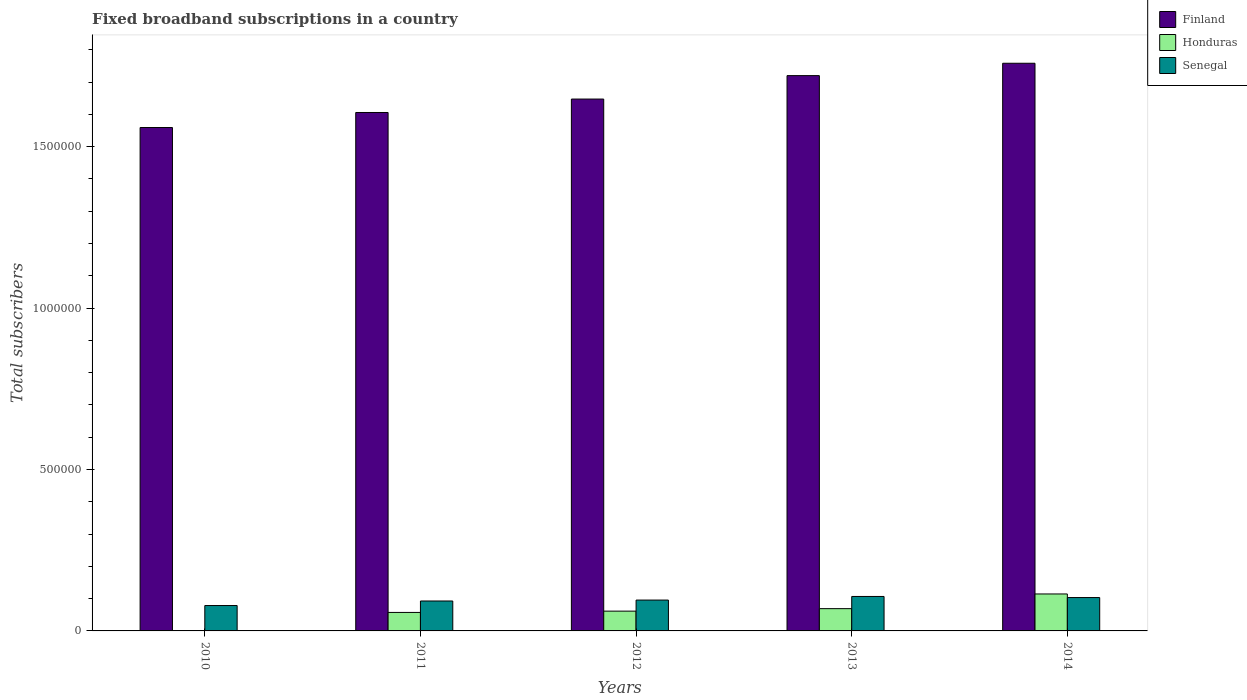How many different coloured bars are there?
Your answer should be compact. 3. Are the number of bars per tick equal to the number of legend labels?
Give a very brief answer. Yes. Are the number of bars on each tick of the X-axis equal?
Your response must be concise. Yes. How many bars are there on the 2nd tick from the left?
Ensure brevity in your answer.  3. What is the number of broadband subscriptions in Finland in 2011?
Your answer should be compact. 1.61e+06. Across all years, what is the maximum number of broadband subscriptions in Finland?
Ensure brevity in your answer.  1.76e+06. Across all years, what is the minimum number of broadband subscriptions in Senegal?
Provide a succinct answer. 7.86e+04. What is the total number of broadband subscriptions in Senegal in the graph?
Keep it short and to the point. 4.77e+05. What is the difference between the number of broadband subscriptions in Honduras in 2012 and that in 2013?
Provide a short and direct response. -7714. What is the difference between the number of broadband subscriptions in Finland in 2010 and the number of broadband subscriptions in Honduras in 2013?
Offer a very short reply. 1.49e+06. What is the average number of broadband subscriptions in Senegal per year?
Your answer should be very brief. 9.54e+04. In the year 2010, what is the difference between the number of broadband subscriptions in Finland and number of broadband subscriptions in Senegal?
Offer a terse response. 1.48e+06. What is the ratio of the number of broadband subscriptions in Senegal in 2012 to that in 2014?
Ensure brevity in your answer.  0.92. Is the difference between the number of broadband subscriptions in Finland in 2013 and 2014 greater than the difference between the number of broadband subscriptions in Senegal in 2013 and 2014?
Ensure brevity in your answer.  No. What is the difference between the highest and the second highest number of broadband subscriptions in Senegal?
Offer a very short reply. 3371. What is the difference between the highest and the lowest number of broadband subscriptions in Senegal?
Provide a succinct answer. 2.81e+04. In how many years, is the number of broadband subscriptions in Honduras greater than the average number of broadband subscriptions in Honduras taken over all years?
Make the answer very short. 3. What does the 2nd bar from the left in 2014 represents?
Offer a terse response. Honduras. What does the 1st bar from the right in 2010 represents?
Offer a very short reply. Senegal. How many bars are there?
Offer a very short reply. 15. Are all the bars in the graph horizontal?
Your answer should be very brief. No. Are the values on the major ticks of Y-axis written in scientific E-notation?
Your answer should be compact. No. Does the graph contain any zero values?
Your response must be concise. No. How many legend labels are there?
Ensure brevity in your answer.  3. What is the title of the graph?
Your response must be concise. Fixed broadband subscriptions in a country. What is the label or title of the Y-axis?
Your response must be concise. Total subscribers. What is the Total subscribers in Finland in 2010?
Offer a very short reply. 1.56e+06. What is the Total subscribers in Honduras in 2010?
Offer a terse response. 1000. What is the Total subscribers of Senegal in 2010?
Your answer should be very brief. 7.86e+04. What is the Total subscribers of Finland in 2011?
Provide a succinct answer. 1.61e+06. What is the Total subscribers of Honduras in 2011?
Ensure brevity in your answer.  5.73e+04. What is the Total subscribers in Senegal in 2011?
Give a very brief answer. 9.27e+04. What is the Total subscribers in Finland in 2012?
Offer a terse response. 1.65e+06. What is the Total subscribers of Honduras in 2012?
Provide a short and direct response. 6.13e+04. What is the Total subscribers in Senegal in 2012?
Offer a very short reply. 9.56e+04. What is the Total subscribers of Finland in 2013?
Your answer should be very brief. 1.72e+06. What is the Total subscribers of Honduras in 2013?
Make the answer very short. 6.90e+04. What is the Total subscribers of Senegal in 2013?
Give a very brief answer. 1.07e+05. What is the Total subscribers of Finland in 2014?
Keep it short and to the point. 1.76e+06. What is the Total subscribers of Honduras in 2014?
Your answer should be compact. 1.14e+05. What is the Total subscribers of Senegal in 2014?
Your response must be concise. 1.03e+05. Across all years, what is the maximum Total subscribers of Finland?
Your answer should be very brief. 1.76e+06. Across all years, what is the maximum Total subscribers of Honduras?
Provide a succinct answer. 1.14e+05. Across all years, what is the maximum Total subscribers in Senegal?
Make the answer very short. 1.07e+05. Across all years, what is the minimum Total subscribers in Finland?
Offer a very short reply. 1.56e+06. Across all years, what is the minimum Total subscribers in Honduras?
Offer a terse response. 1000. Across all years, what is the minimum Total subscribers of Senegal?
Provide a short and direct response. 7.86e+04. What is the total Total subscribers in Finland in the graph?
Your answer should be compact. 8.29e+06. What is the total Total subscribers in Honduras in the graph?
Your response must be concise. 3.03e+05. What is the total Total subscribers in Senegal in the graph?
Offer a terse response. 4.77e+05. What is the difference between the Total subscribers of Finland in 2010 and that in 2011?
Offer a very short reply. -4.66e+04. What is the difference between the Total subscribers of Honduras in 2010 and that in 2011?
Give a very brief answer. -5.63e+04. What is the difference between the Total subscribers in Senegal in 2010 and that in 2011?
Your answer should be very brief. -1.41e+04. What is the difference between the Total subscribers in Finland in 2010 and that in 2012?
Your answer should be compact. -8.82e+04. What is the difference between the Total subscribers of Honduras in 2010 and that in 2012?
Provide a succinct answer. -6.03e+04. What is the difference between the Total subscribers of Senegal in 2010 and that in 2012?
Your answer should be very brief. -1.69e+04. What is the difference between the Total subscribers in Finland in 2010 and that in 2013?
Your answer should be compact. -1.61e+05. What is the difference between the Total subscribers of Honduras in 2010 and that in 2013?
Keep it short and to the point. -6.80e+04. What is the difference between the Total subscribers of Senegal in 2010 and that in 2013?
Your answer should be very brief. -2.81e+04. What is the difference between the Total subscribers of Finland in 2010 and that in 2014?
Keep it short and to the point. -1.99e+05. What is the difference between the Total subscribers in Honduras in 2010 and that in 2014?
Make the answer very short. -1.13e+05. What is the difference between the Total subscribers in Senegal in 2010 and that in 2014?
Provide a short and direct response. -2.47e+04. What is the difference between the Total subscribers of Finland in 2011 and that in 2012?
Your answer should be compact. -4.16e+04. What is the difference between the Total subscribers of Honduras in 2011 and that in 2012?
Make the answer very short. -3987. What is the difference between the Total subscribers of Senegal in 2011 and that in 2012?
Ensure brevity in your answer.  -2848. What is the difference between the Total subscribers of Finland in 2011 and that in 2013?
Give a very brief answer. -1.14e+05. What is the difference between the Total subscribers in Honduras in 2011 and that in 2013?
Offer a terse response. -1.17e+04. What is the difference between the Total subscribers of Senegal in 2011 and that in 2013?
Your answer should be compact. -1.40e+04. What is the difference between the Total subscribers of Finland in 2011 and that in 2014?
Keep it short and to the point. -1.52e+05. What is the difference between the Total subscribers of Honduras in 2011 and that in 2014?
Offer a very short reply. -5.72e+04. What is the difference between the Total subscribers in Senegal in 2011 and that in 2014?
Provide a succinct answer. -1.06e+04. What is the difference between the Total subscribers in Finland in 2012 and that in 2013?
Offer a terse response. -7.26e+04. What is the difference between the Total subscribers in Honduras in 2012 and that in 2013?
Offer a very short reply. -7714. What is the difference between the Total subscribers of Senegal in 2012 and that in 2013?
Offer a terse response. -1.12e+04. What is the difference between the Total subscribers of Finland in 2012 and that in 2014?
Give a very brief answer. -1.11e+05. What is the difference between the Total subscribers of Honduras in 2012 and that in 2014?
Offer a very short reply. -5.32e+04. What is the difference between the Total subscribers in Senegal in 2012 and that in 2014?
Provide a succinct answer. -7801. What is the difference between the Total subscribers in Finland in 2013 and that in 2014?
Provide a short and direct response. -3.83e+04. What is the difference between the Total subscribers in Honduras in 2013 and that in 2014?
Offer a very short reply. -4.55e+04. What is the difference between the Total subscribers in Senegal in 2013 and that in 2014?
Your answer should be very brief. 3371. What is the difference between the Total subscribers in Finland in 2010 and the Total subscribers in Honduras in 2011?
Ensure brevity in your answer.  1.50e+06. What is the difference between the Total subscribers of Finland in 2010 and the Total subscribers of Senegal in 2011?
Give a very brief answer. 1.47e+06. What is the difference between the Total subscribers in Honduras in 2010 and the Total subscribers in Senegal in 2011?
Ensure brevity in your answer.  -9.17e+04. What is the difference between the Total subscribers of Finland in 2010 and the Total subscribers of Honduras in 2012?
Your answer should be very brief. 1.50e+06. What is the difference between the Total subscribers of Finland in 2010 and the Total subscribers of Senegal in 2012?
Offer a very short reply. 1.46e+06. What is the difference between the Total subscribers in Honduras in 2010 and the Total subscribers in Senegal in 2012?
Keep it short and to the point. -9.46e+04. What is the difference between the Total subscribers of Finland in 2010 and the Total subscribers of Honduras in 2013?
Keep it short and to the point. 1.49e+06. What is the difference between the Total subscribers in Finland in 2010 and the Total subscribers in Senegal in 2013?
Ensure brevity in your answer.  1.45e+06. What is the difference between the Total subscribers in Honduras in 2010 and the Total subscribers in Senegal in 2013?
Your response must be concise. -1.06e+05. What is the difference between the Total subscribers in Finland in 2010 and the Total subscribers in Honduras in 2014?
Offer a very short reply. 1.44e+06. What is the difference between the Total subscribers in Finland in 2010 and the Total subscribers in Senegal in 2014?
Ensure brevity in your answer.  1.46e+06. What is the difference between the Total subscribers in Honduras in 2010 and the Total subscribers in Senegal in 2014?
Offer a very short reply. -1.02e+05. What is the difference between the Total subscribers of Finland in 2011 and the Total subscribers of Honduras in 2012?
Your answer should be very brief. 1.54e+06. What is the difference between the Total subscribers in Finland in 2011 and the Total subscribers in Senegal in 2012?
Your answer should be very brief. 1.51e+06. What is the difference between the Total subscribers of Honduras in 2011 and the Total subscribers of Senegal in 2012?
Give a very brief answer. -3.83e+04. What is the difference between the Total subscribers in Finland in 2011 and the Total subscribers in Honduras in 2013?
Make the answer very short. 1.54e+06. What is the difference between the Total subscribers in Finland in 2011 and the Total subscribers in Senegal in 2013?
Offer a very short reply. 1.50e+06. What is the difference between the Total subscribers in Honduras in 2011 and the Total subscribers in Senegal in 2013?
Offer a terse response. -4.94e+04. What is the difference between the Total subscribers in Finland in 2011 and the Total subscribers in Honduras in 2014?
Ensure brevity in your answer.  1.49e+06. What is the difference between the Total subscribers of Finland in 2011 and the Total subscribers of Senegal in 2014?
Your answer should be compact. 1.50e+06. What is the difference between the Total subscribers of Honduras in 2011 and the Total subscribers of Senegal in 2014?
Make the answer very short. -4.61e+04. What is the difference between the Total subscribers in Finland in 2012 and the Total subscribers in Honduras in 2013?
Give a very brief answer. 1.58e+06. What is the difference between the Total subscribers in Finland in 2012 and the Total subscribers in Senegal in 2013?
Offer a terse response. 1.54e+06. What is the difference between the Total subscribers in Honduras in 2012 and the Total subscribers in Senegal in 2013?
Give a very brief answer. -4.55e+04. What is the difference between the Total subscribers of Finland in 2012 and the Total subscribers of Honduras in 2014?
Provide a succinct answer. 1.53e+06. What is the difference between the Total subscribers in Finland in 2012 and the Total subscribers in Senegal in 2014?
Provide a short and direct response. 1.54e+06. What is the difference between the Total subscribers in Honduras in 2012 and the Total subscribers in Senegal in 2014?
Provide a short and direct response. -4.21e+04. What is the difference between the Total subscribers in Finland in 2013 and the Total subscribers in Honduras in 2014?
Your answer should be very brief. 1.61e+06. What is the difference between the Total subscribers of Finland in 2013 and the Total subscribers of Senegal in 2014?
Keep it short and to the point. 1.62e+06. What is the difference between the Total subscribers of Honduras in 2013 and the Total subscribers of Senegal in 2014?
Your answer should be very brief. -3.44e+04. What is the average Total subscribers in Finland per year?
Your answer should be very brief. 1.66e+06. What is the average Total subscribers in Honduras per year?
Your response must be concise. 6.06e+04. What is the average Total subscribers in Senegal per year?
Provide a short and direct response. 9.54e+04. In the year 2010, what is the difference between the Total subscribers of Finland and Total subscribers of Honduras?
Provide a short and direct response. 1.56e+06. In the year 2010, what is the difference between the Total subscribers of Finland and Total subscribers of Senegal?
Give a very brief answer. 1.48e+06. In the year 2010, what is the difference between the Total subscribers of Honduras and Total subscribers of Senegal?
Your answer should be very brief. -7.76e+04. In the year 2011, what is the difference between the Total subscribers in Finland and Total subscribers in Honduras?
Give a very brief answer. 1.55e+06. In the year 2011, what is the difference between the Total subscribers of Finland and Total subscribers of Senegal?
Provide a short and direct response. 1.51e+06. In the year 2011, what is the difference between the Total subscribers of Honduras and Total subscribers of Senegal?
Your response must be concise. -3.54e+04. In the year 2012, what is the difference between the Total subscribers in Finland and Total subscribers in Honduras?
Offer a terse response. 1.59e+06. In the year 2012, what is the difference between the Total subscribers of Finland and Total subscribers of Senegal?
Offer a terse response. 1.55e+06. In the year 2012, what is the difference between the Total subscribers in Honduras and Total subscribers in Senegal?
Provide a succinct answer. -3.43e+04. In the year 2013, what is the difference between the Total subscribers in Finland and Total subscribers in Honduras?
Make the answer very short. 1.65e+06. In the year 2013, what is the difference between the Total subscribers of Finland and Total subscribers of Senegal?
Offer a very short reply. 1.61e+06. In the year 2013, what is the difference between the Total subscribers in Honduras and Total subscribers in Senegal?
Provide a short and direct response. -3.77e+04. In the year 2014, what is the difference between the Total subscribers in Finland and Total subscribers in Honduras?
Your answer should be very brief. 1.64e+06. In the year 2014, what is the difference between the Total subscribers in Finland and Total subscribers in Senegal?
Provide a short and direct response. 1.66e+06. In the year 2014, what is the difference between the Total subscribers in Honduras and Total subscribers in Senegal?
Give a very brief answer. 1.11e+04. What is the ratio of the Total subscribers of Finland in 2010 to that in 2011?
Your response must be concise. 0.97. What is the ratio of the Total subscribers of Honduras in 2010 to that in 2011?
Provide a short and direct response. 0.02. What is the ratio of the Total subscribers of Senegal in 2010 to that in 2011?
Your answer should be compact. 0.85. What is the ratio of the Total subscribers of Finland in 2010 to that in 2012?
Ensure brevity in your answer.  0.95. What is the ratio of the Total subscribers in Honduras in 2010 to that in 2012?
Give a very brief answer. 0.02. What is the ratio of the Total subscribers of Senegal in 2010 to that in 2012?
Provide a short and direct response. 0.82. What is the ratio of the Total subscribers of Finland in 2010 to that in 2013?
Offer a very short reply. 0.91. What is the ratio of the Total subscribers of Honduras in 2010 to that in 2013?
Offer a very short reply. 0.01. What is the ratio of the Total subscribers of Senegal in 2010 to that in 2013?
Make the answer very short. 0.74. What is the ratio of the Total subscribers in Finland in 2010 to that in 2014?
Your answer should be compact. 0.89. What is the ratio of the Total subscribers of Honduras in 2010 to that in 2014?
Give a very brief answer. 0.01. What is the ratio of the Total subscribers of Senegal in 2010 to that in 2014?
Your answer should be very brief. 0.76. What is the ratio of the Total subscribers in Finland in 2011 to that in 2012?
Ensure brevity in your answer.  0.97. What is the ratio of the Total subscribers of Honduras in 2011 to that in 2012?
Your answer should be compact. 0.93. What is the ratio of the Total subscribers in Senegal in 2011 to that in 2012?
Your answer should be compact. 0.97. What is the ratio of the Total subscribers in Finland in 2011 to that in 2013?
Give a very brief answer. 0.93. What is the ratio of the Total subscribers of Honduras in 2011 to that in 2013?
Your answer should be compact. 0.83. What is the ratio of the Total subscribers in Senegal in 2011 to that in 2013?
Keep it short and to the point. 0.87. What is the ratio of the Total subscribers of Finland in 2011 to that in 2014?
Your answer should be compact. 0.91. What is the ratio of the Total subscribers in Honduras in 2011 to that in 2014?
Provide a succinct answer. 0.5. What is the ratio of the Total subscribers in Senegal in 2011 to that in 2014?
Ensure brevity in your answer.  0.9. What is the ratio of the Total subscribers in Finland in 2012 to that in 2013?
Your response must be concise. 0.96. What is the ratio of the Total subscribers in Honduras in 2012 to that in 2013?
Offer a terse response. 0.89. What is the ratio of the Total subscribers of Senegal in 2012 to that in 2013?
Make the answer very short. 0.9. What is the ratio of the Total subscribers in Finland in 2012 to that in 2014?
Provide a short and direct response. 0.94. What is the ratio of the Total subscribers of Honduras in 2012 to that in 2014?
Offer a terse response. 0.54. What is the ratio of the Total subscribers in Senegal in 2012 to that in 2014?
Provide a short and direct response. 0.92. What is the ratio of the Total subscribers of Finland in 2013 to that in 2014?
Your response must be concise. 0.98. What is the ratio of the Total subscribers of Honduras in 2013 to that in 2014?
Offer a very short reply. 0.6. What is the ratio of the Total subscribers of Senegal in 2013 to that in 2014?
Your response must be concise. 1.03. What is the difference between the highest and the second highest Total subscribers in Finland?
Your answer should be compact. 3.83e+04. What is the difference between the highest and the second highest Total subscribers of Honduras?
Provide a short and direct response. 4.55e+04. What is the difference between the highest and the second highest Total subscribers of Senegal?
Provide a short and direct response. 3371. What is the difference between the highest and the lowest Total subscribers in Finland?
Your answer should be compact. 1.99e+05. What is the difference between the highest and the lowest Total subscribers of Honduras?
Offer a very short reply. 1.13e+05. What is the difference between the highest and the lowest Total subscribers of Senegal?
Provide a succinct answer. 2.81e+04. 